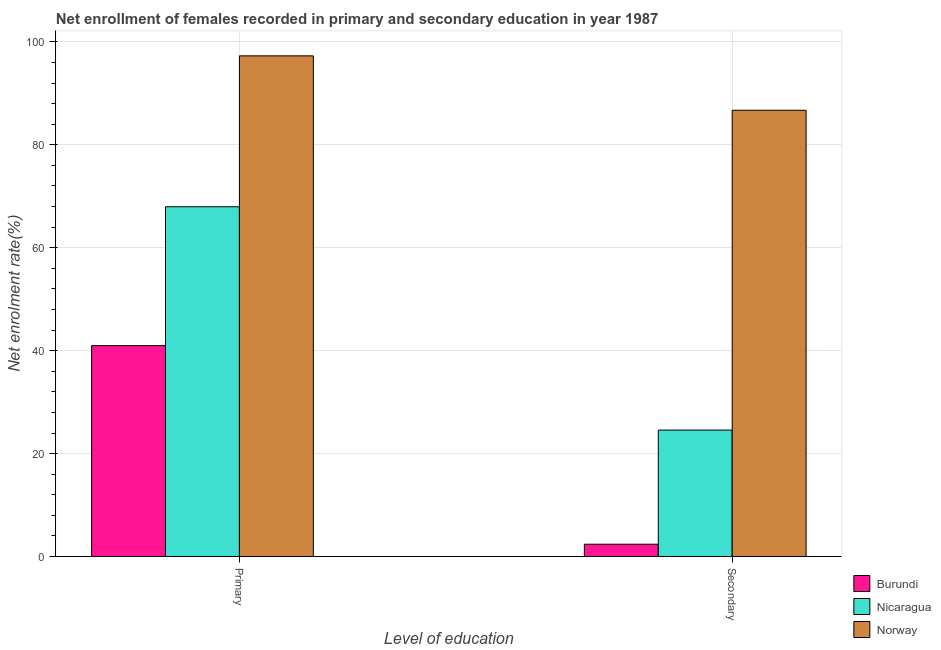How many different coloured bars are there?
Offer a very short reply. 3. How many groups of bars are there?
Provide a succinct answer. 2. Are the number of bars on each tick of the X-axis equal?
Provide a short and direct response. Yes. How many bars are there on the 2nd tick from the left?
Your response must be concise. 3. What is the label of the 2nd group of bars from the left?
Your answer should be compact. Secondary. What is the enrollment rate in primary education in Burundi?
Ensure brevity in your answer.  40.98. Across all countries, what is the maximum enrollment rate in primary education?
Offer a very short reply. 97.29. Across all countries, what is the minimum enrollment rate in primary education?
Ensure brevity in your answer.  40.98. In which country was the enrollment rate in secondary education minimum?
Your answer should be compact. Burundi. What is the total enrollment rate in primary education in the graph?
Your answer should be very brief. 206.23. What is the difference between the enrollment rate in primary education in Norway and that in Burundi?
Provide a short and direct response. 56.31. What is the difference between the enrollment rate in secondary education in Norway and the enrollment rate in primary education in Nicaragua?
Offer a terse response. 18.75. What is the average enrollment rate in primary education per country?
Your answer should be compact. 68.74. What is the difference between the enrollment rate in primary education and enrollment rate in secondary education in Norway?
Ensure brevity in your answer.  10.57. In how many countries, is the enrollment rate in secondary education greater than 56 %?
Provide a succinct answer. 1. What is the ratio of the enrollment rate in secondary education in Burundi to that in Nicaragua?
Offer a terse response. 0.1. What does the 1st bar from the left in Secondary represents?
Your response must be concise. Burundi. What does the 2nd bar from the right in Secondary represents?
Provide a succinct answer. Nicaragua. Are all the bars in the graph horizontal?
Offer a terse response. No. Does the graph contain grids?
Your response must be concise. Yes. Where does the legend appear in the graph?
Provide a succinct answer. Bottom right. What is the title of the graph?
Make the answer very short. Net enrollment of females recorded in primary and secondary education in year 1987. What is the label or title of the X-axis?
Ensure brevity in your answer.  Level of education. What is the label or title of the Y-axis?
Offer a very short reply. Net enrolment rate(%). What is the Net enrolment rate(%) of Burundi in Primary?
Provide a short and direct response. 40.98. What is the Net enrolment rate(%) in Nicaragua in Primary?
Provide a short and direct response. 67.96. What is the Net enrolment rate(%) in Norway in Primary?
Your answer should be very brief. 97.29. What is the Net enrolment rate(%) of Burundi in Secondary?
Your answer should be compact. 2.39. What is the Net enrolment rate(%) in Nicaragua in Secondary?
Ensure brevity in your answer.  24.57. What is the Net enrolment rate(%) in Norway in Secondary?
Your response must be concise. 86.72. Across all Level of education, what is the maximum Net enrolment rate(%) in Burundi?
Give a very brief answer. 40.98. Across all Level of education, what is the maximum Net enrolment rate(%) in Nicaragua?
Your answer should be very brief. 67.96. Across all Level of education, what is the maximum Net enrolment rate(%) in Norway?
Your answer should be very brief. 97.29. Across all Level of education, what is the minimum Net enrolment rate(%) in Burundi?
Your answer should be very brief. 2.39. Across all Level of education, what is the minimum Net enrolment rate(%) in Nicaragua?
Your response must be concise. 24.57. Across all Level of education, what is the minimum Net enrolment rate(%) of Norway?
Ensure brevity in your answer.  86.72. What is the total Net enrolment rate(%) of Burundi in the graph?
Offer a very short reply. 43.37. What is the total Net enrolment rate(%) in Nicaragua in the graph?
Give a very brief answer. 92.53. What is the total Net enrolment rate(%) in Norway in the graph?
Provide a succinct answer. 184. What is the difference between the Net enrolment rate(%) of Burundi in Primary and that in Secondary?
Keep it short and to the point. 38.59. What is the difference between the Net enrolment rate(%) in Nicaragua in Primary and that in Secondary?
Ensure brevity in your answer.  43.4. What is the difference between the Net enrolment rate(%) of Norway in Primary and that in Secondary?
Your answer should be very brief. 10.57. What is the difference between the Net enrolment rate(%) of Burundi in Primary and the Net enrolment rate(%) of Nicaragua in Secondary?
Keep it short and to the point. 16.41. What is the difference between the Net enrolment rate(%) of Burundi in Primary and the Net enrolment rate(%) of Norway in Secondary?
Provide a short and direct response. -45.74. What is the difference between the Net enrolment rate(%) in Nicaragua in Primary and the Net enrolment rate(%) in Norway in Secondary?
Provide a short and direct response. -18.75. What is the average Net enrolment rate(%) in Burundi per Level of education?
Offer a very short reply. 21.68. What is the average Net enrolment rate(%) in Nicaragua per Level of education?
Offer a terse response. 46.27. What is the average Net enrolment rate(%) of Norway per Level of education?
Offer a terse response. 92. What is the difference between the Net enrolment rate(%) of Burundi and Net enrolment rate(%) of Nicaragua in Primary?
Make the answer very short. -26.98. What is the difference between the Net enrolment rate(%) of Burundi and Net enrolment rate(%) of Norway in Primary?
Provide a short and direct response. -56.31. What is the difference between the Net enrolment rate(%) of Nicaragua and Net enrolment rate(%) of Norway in Primary?
Offer a terse response. -29.32. What is the difference between the Net enrolment rate(%) of Burundi and Net enrolment rate(%) of Nicaragua in Secondary?
Your answer should be very brief. -22.18. What is the difference between the Net enrolment rate(%) in Burundi and Net enrolment rate(%) in Norway in Secondary?
Make the answer very short. -84.33. What is the difference between the Net enrolment rate(%) in Nicaragua and Net enrolment rate(%) in Norway in Secondary?
Ensure brevity in your answer.  -62.15. What is the ratio of the Net enrolment rate(%) of Burundi in Primary to that in Secondary?
Give a very brief answer. 17.16. What is the ratio of the Net enrolment rate(%) of Nicaragua in Primary to that in Secondary?
Your answer should be very brief. 2.77. What is the ratio of the Net enrolment rate(%) in Norway in Primary to that in Secondary?
Keep it short and to the point. 1.12. What is the difference between the highest and the second highest Net enrolment rate(%) of Burundi?
Your response must be concise. 38.59. What is the difference between the highest and the second highest Net enrolment rate(%) of Nicaragua?
Offer a terse response. 43.4. What is the difference between the highest and the second highest Net enrolment rate(%) of Norway?
Your answer should be compact. 10.57. What is the difference between the highest and the lowest Net enrolment rate(%) of Burundi?
Ensure brevity in your answer.  38.59. What is the difference between the highest and the lowest Net enrolment rate(%) of Nicaragua?
Your response must be concise. 43.4. What is the difference between the highest and the lowest Net enrolment rate(%) of Norway?
Ensure brevity in your answer.  10.57. 